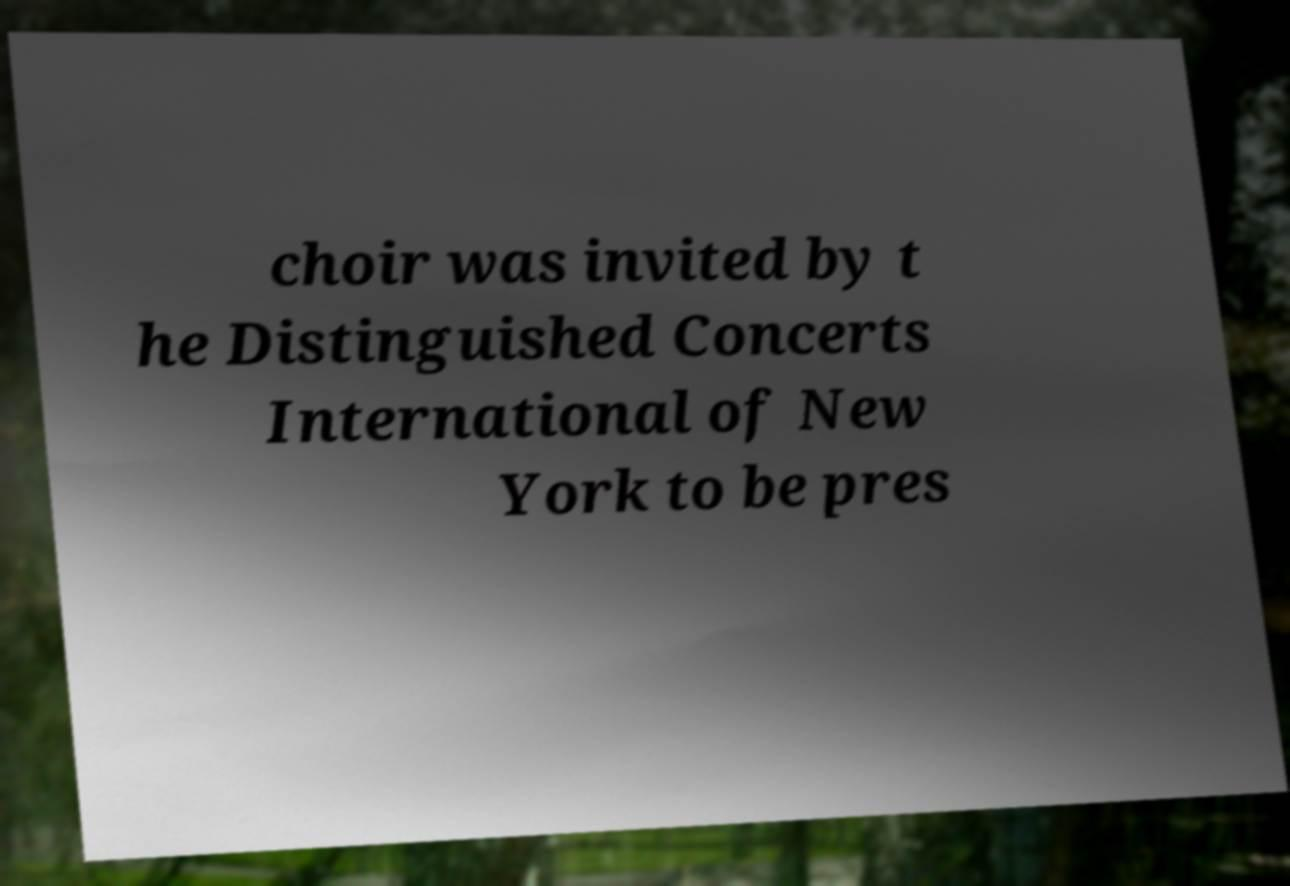For documentation purposes, I need the text within this image transcribed. Could you provide that? choir was invited by t he Distinguished Concerts International of New York to be pres 